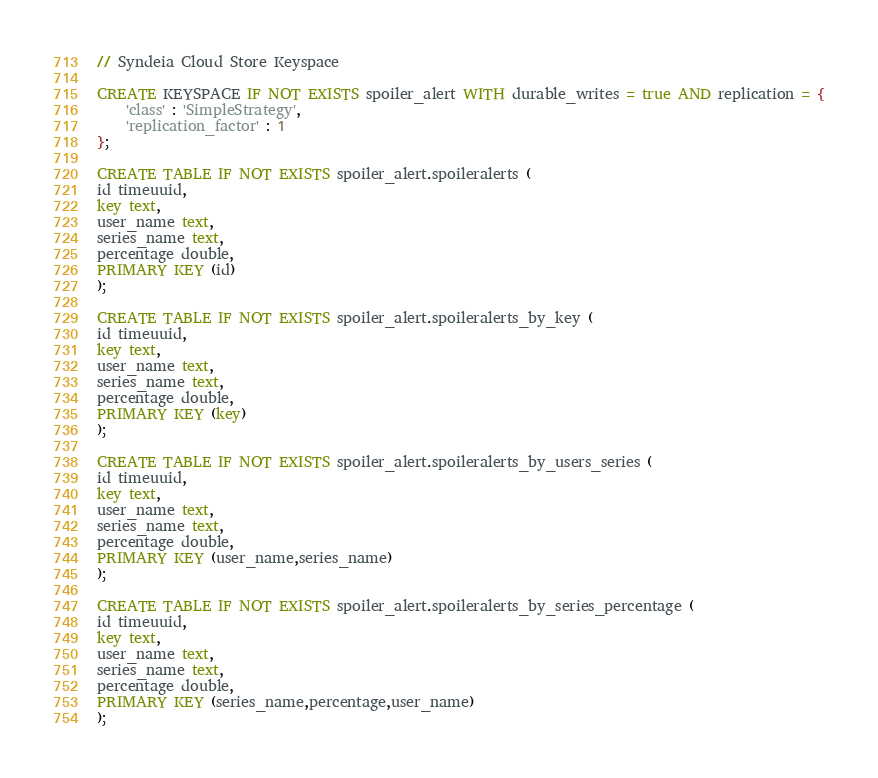<code> <loc_0><loc_0><loc_500><loc_500><_SQL_>// Syndeia Cloud Store Keyspace

CREATE KEYSPACE IF NOT EXISTS spoiler_alert WITH durable_writes = true AND replication = {
	'class' : 'SimpleStrategy',
	'replication_factor' : 1
};

CREATE TABLE IF NOT EXISTS spoiler_alert.spoileralerts (
id timeuuid,
key text,
user_name text,
series_name text,
percentage double,
PRIMARY KEY (id)
);

CREATE TABLE IF NOT EXISTS spoiler_alert.spoileralerts_by_key (
id timeuuid,
key text,
user_name text,
series_name text,
percentage double,
PRIMARY KEY (key)
);

CREATE TABLE IF NOT EXISTS spoiler_alert.spoileralerts_by_users_series (
id timeuuid,
key text,
user_name text,
series_name text,
percentage double,
PRIMARY KEY (user_name,series_name)
);

CREATE TABLE IF NOT EXISTS spoiler_alert.spoileralerts_by_series_percentage (
id timeuuid,
key text,
user_name text,
series_name text,
percentage double,
PRIMARY KEY (series_name,percentage,user_name)
);


</code> 